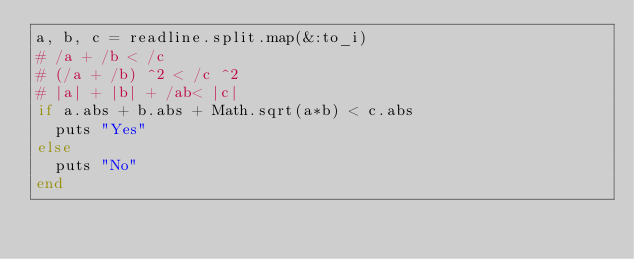<code> <loc_0><loc_0><loc_500><loc_500><_Ruby_>a, b, c = readline.split.map(&:to_i)
# /a + /b < /c
# (/a + /b) ^2 < /c ^2
# |a| + |b| + /ab< |c|
if a.abs + b.abs + Math.sqrt(a*b) < c.abs
  puts "Yes"
else
  puts "No"
end</code> 